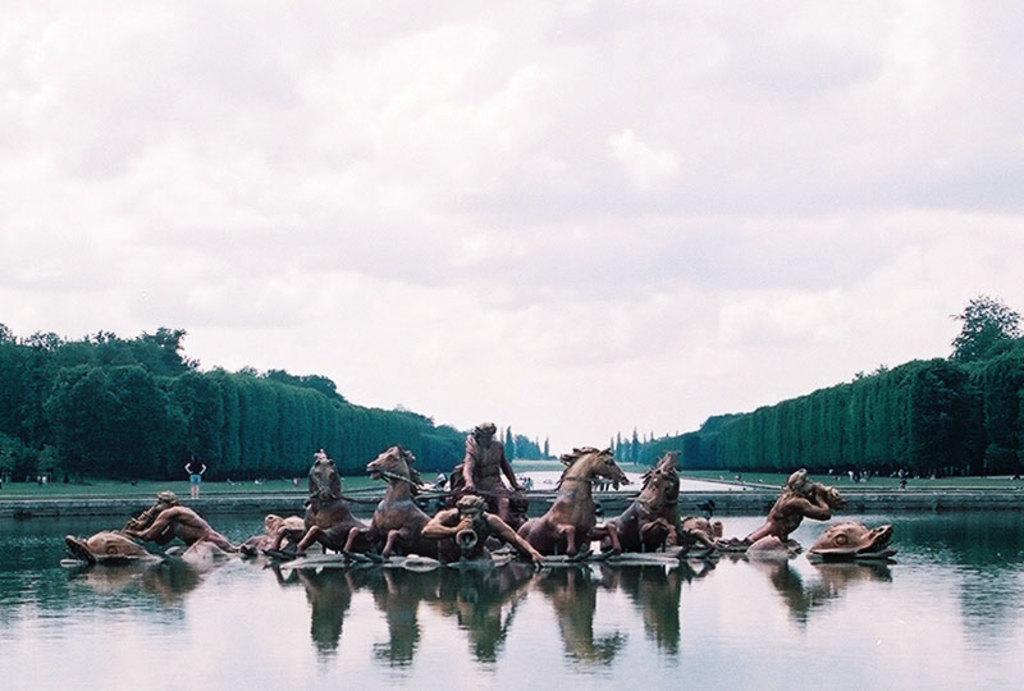Please provide a concise description of this image. In the image there are sculptures in the water surface and behind the water surface there is grass and trees. 